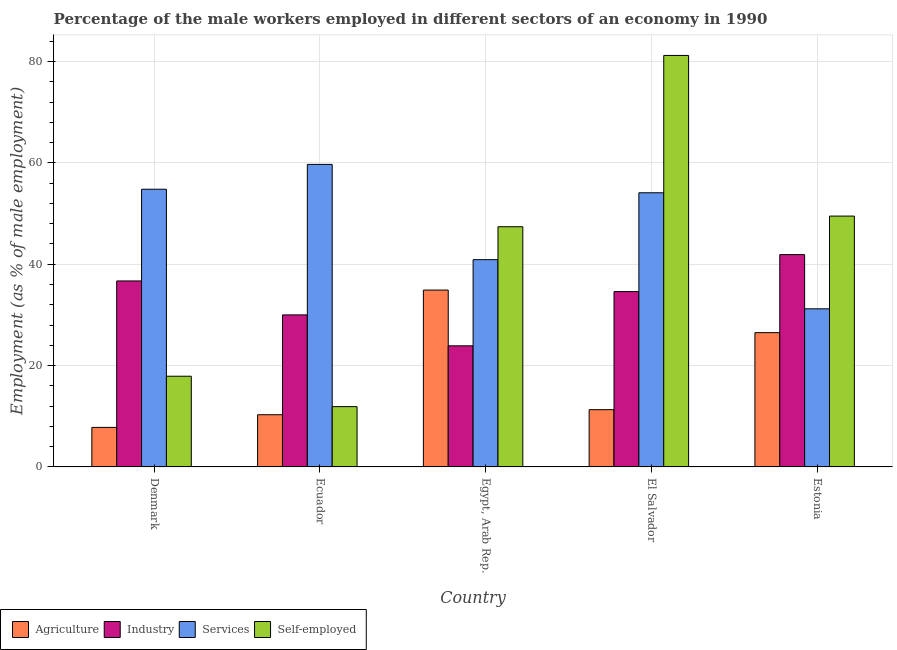How many groups of bars are there?
Your answer should be very brief. 5. How many bars are there on the 1st tick from the left?
Offer a very short reply. 4. What is the label of the 5th group of bars from the left?
Provide a succinct answer. Estonia. In how many cases, is the number of bars for a given country not equal to the number of legend labels?
Make the answer very short. 0. What is the percentage of male workers in industry in Estonia?
Provide a short and direct response. 41.9. Across all countries, what is the maximum percentage of male workers in industry?
Offer a terse response. 41.9. Across all countries, what is the minimum percentage of male workers in services?
Give a very brief answer. 31.2. In which country was the percentage of self employed male workers maximum?
Provide a short and direct response. El Salvador. In which country was the percentage of male workers in services minimum?
Your response must be concise. Estonia. What is the total percentage of male workers in services in the graph?
Your answer should be very brief. 240.7. What is the difference between the percentage of male workers in industry in Ecuador and that in Estonia?
Give a very brief answer. -11.9. What is the difference between the percentage of male workers in industry in Ecuador and the percentage of male workers in agriculture in Egypt, Arab Rep.?
Your answer should be compact. -4.9. What is the average percentage of male workers in industry per country?
Your answer should be compact. 33.42. What is the difference between the percentage of male workers in industry and percentage of male workers in services in Egypt, Arab Rep.?
Your answer should be compact. -17. In how many countries, is the percentage of male workers in agriculture greater than 28 %?
Keep it short and to the point. 1. What is the ratio of the percentage of male workers in services in Denmark to that in El Salvador?
Provide a succinct answer. 1.01. What is the difference between the highest and the second highest percentage of male workers in agriculture?
Provide a succinct answer. 8.4. What is the difference between the highest and the lowest percentage of male workers in services?
Your response must be concise. 28.5. Is the sum of the percentage of male workers in industry in Egypt, Arab Rep. and Estonia greater than the maximum percentage of self employed male workers across all countries?
Offer a terse response. No. Is it the case that in every country, the sum of the percentage of self employed male workers and percentage of male workers in agriculture is greater than the sum of percentage of male workers in services and percentage of male workers in industry?
Offer a terse response. No. What does the 2nd bar from the left in El Salvador represents?
Make the answer very short. Industry. What does the 3rd bar from the right in Ecuador represents?
Provide a succinct answer. Industry. How many bars are there?
Provide a short and direct response. 20. Are all the bars in the graph horizontal?
Offer a very short reply. No. How many countries are there in the graph?
Your answer should be compact. 5. Are the values on the major ticks of Y-axis written in scientific E-notation?
Offer a very short reply. No. Does the graph contain any zero values?
Your answer should be compact. No. Where does the legend appear in the graph?
Keep it short and to the point. Bottom left. How many legend labels are there?
Offer a terse response. 4. How are the legend labels stacked?
Your answer should be very brief. Horizontal. What is the title of the graph?
Your response must be concise. Percentage of the male workers employed in different sectors of an economy in 1990. Does "International Monetary Fund" appear as one of the legend labels in the graph?
Make the answer very short. No. What is the label or title of the X-axis?
Keep it short and to the point. Country. What is the label or title of the Y-axis?
Your response must be concise. Employment (as % of male employment). What is the Employment (as % of male employment) of Agriculture in Denmark?
Provide a succinct answer. 7.8. What is the Employment (as % of male employment) of Industry in Denmark?
Offer a terse response. 36.7. What is the Employment (as % of male employment) in Services in Denmark?
Give a very brief answer. 54.8. What is the Employment (as % of male employment) in Self-employed in Denmark?
Provide a short and direct response. 17.9. What is the Employment (as % of male employment) in Agriculture in Ecuador?
Your response must be concise. 10.3. What is the Employment (as % of male employment) of Services in Ecuador?
Make the answer very short. 59.7. What is the Employment (as % of male employment) of Self-employed in Ecuador?
Offer a very short reply. 11.9. What is the Employment (as % of male employment) of Agriculture in Egypt, Arab Rep.?
Provide a succinct answer. 34.9. What is the Employment (as % of male employment) in Industry in Egypt, Arab Rep.?
Offer a terse response. 23.9. What is the Employment (as % of male employment) of Services in Egypt, Arab Rep.?
Ensure brevity in your answer.  40.9. What is the Employment (as % of male employment) of Self-employed in Egypt, Arab Rep.?
Provide a succinct answer. 47.4. What is the Employment (as % of male employment) in Agriculture in El Salvador?
Keep it short and to the point. 11.3. What is the Employment (as % of male employment) of Industry in El Salvador?
Provide a succinct answer. 34.6. What is the Employment (as % of male employment) in Services in El Salvador?
Offer a terse response. 54.1. What is the Employment (as % of male employment) in Self-employed in El Salvador?
Your answer should be compact. 81.2. What is the Employment (as % of male employment) of Industry in Estonia?
Your response must be concise. 41.9. What is the Employment (as % of male employment) in Services in Estonia?
Your answer should be very brief. 31.2. What is the Employment (as % of male employment) in Self-employed in Estonia?
Give a very brief answer. 49.5. Across all countries, what is the maximum Employment (as % of male employment) in Agriculture?
Your answer should be compact. 34.9. Across all countries, what is the maximum Employment (as % of male employment) in Industry?
Ensure brevity in your answer.  41.9. Across all countries, what is the maximum Employment (as % of male employment) of Services?
Offer a terse response. 59.7. Across all countries, what is the maximum Employment (as % of male employment) of Self-employed?
Provide a succinct answer. 81.2. Across all countries, what is the minimum Employment (as % of male employment) in Agriculture?
Your answer should be very brief. 7.8. Across all countries, what is the minimum Employment (as % of male employment) of Industry?
Ensure brevity in your answer.  23.9. Across all countries, what is the minimum Employment (as % of male employment) of Services?
Ensure brevity in your answer.  31.2. Across all countries, what is the minimum Employment (as % of male employment) of Self-employed?
Provide a succinct answer. 11.9. What is the total Employment (as % of male employment) of Agriculture in the graph?
Offer a terse response. 90.8. What is the total Employment (as % of male employment) of Industry in the graph?
Offer a terse response. 167.1. What is the total Employment (as % of male employment) in Services in the graph?
Provide a succinct answer. 240.7. What is the total Employment (as % of male employment) in Self-employed in the graph?
Your response must be concise. 207.9. What is the difference between the Employment (as % of male employment) of Agriculture in Denmark and that in Ecuador?
Ensure brevity in your answer.  -2.5. What is the difference between the Employment (as % of male employment) of Services in Denmark and that in Ecuador?
Offer a very short reply. -4.9. What is the difference between the Employment (as % of male employment) of Agriculture in Denmark and that in Egypt, Arab Rep.?
Keep it short and to the point. -27.1. What is the difference between the Employment (as % of male employment) of Industry in Denmark and that in Egypt, Arab Rep.?
Your answer should be compact. 12.8. What is the difference between the Employment (as % of male employment) of Services in Denmark and that in Egypt, Arab Rep.?
Offer a terse response. 13.9. What is the difference between the Employment (as % of male employment) in Self-employed in Denmark and that in Egypt, Arab Rep.?
Your answer should be compact. -29.5. What is the difference between the Employment (as % of male employment) of Industry in Denmark and that in El Salvador?
Give a very brief answer. 2.1. What is the difference between the Employment (as % of male employment) in Self-employed in Denmark and that in El Salvador?
Your answer should be very brief. -63.3. What is the difference between the Employment (as % of male employment) in Agriculture in Denmark and that in Estonia?
Your response must be concise. -18.7. What is the difference between the Employment (as % of male employment) of Services in Denmark and that in Estonia?
Make the answer very short. 23.6. What is the difference between the Employment (as % of male employment) of Self-employed in Denmark and that in Estonia?
Provide a short and direct response. -31.6. What is the difference between the Employment (as % of male employment) of Agriculture in Ecuador and that in Egypt, Arab Rep.?
Make the answer very short. -24.6. What is the difference between the Employment (as % of male employment) of Self-employed in Ecuador and that in Egypt, Arab Rep.?
Provide a short and direct response. -35.5. What is the difference between the Employment (as % of male employment) in Agriculture in Ecuador and that in El Salvador?
Your answer should be compact. -1. What is the difference between the Employment (as % of male employment) of Self-employed in Ecuador and that in El Salvador?
Ensure brevity in your answer.  -69.3. What is the difference between the Employment (as % of male employment) of Agriculture in Ecuador and that in Estonia?
Offer a very short reply. -16.2. What is the difference between the Employment (as % of male employment) in Services in Ecuador and that in Estonia?
Offer a terse response. 28.5. What is the difference between the Employment (as % of male employment) in Self-employed in Ecuador and that in Estonia?
Your answer should be very brief. -37.6. What is the difference between the Employment (as % of male employment) in Agriculture in Egypt, Arab Rep. and that in El Salvador?
Offer a terse response. 23.6. What is the difference between the Employment (as % of male employment) in Services in Egypt, Arab Rep. and that in El Salvador?
Keep it short and to the point. -13.2. What is the difference between the Employment (as % of male employment) in Self-employed in Egypt, Arab Rep. and that in El Salvador?
Keep it short and to the point. -33.8. What is the difference between the Employment (as % of male employment) of Agriculture in El Salvador and that in Estonia?
Offer a very short reply. -15.2. What is the difference between the Employment (as % of male employment) of Industry in El Salvador and that in Estonia?
Give a very brief answer. -7.3. What is the difference between the Employment (as % of male employment) of Services in El Salvador and that in Estonia?
Make the answer very short. 22.9. What is the difference between the Employment (as % of male employment) of Self-employed in El Salvador and that in Estonia?
Keep it short and to the point. 31.7. What is the difference between the Employment (as % of male employment) of Agriculture in Denmark and the Employment (as % of male employment) of Industry in Ecuador?
Offer a very short reply. -22.2. What is the difference between the Employment (as % of male employment) of Agriculture in Denmark and the Employment (as % of male employment) of Services in Ecuador?
Your answer should be very brief. -51.9. What is the difference between the Employment (as % of male employment) of Industry in Denmark and the Employment (as % of male employment) of Services in Ecuador?
Provide a succinct answer. -23. What is the difference between the Employment (as % of male employment) in Industry in Denmark and the Employment (as % of male employment) in Self-employed in Ecuador?
Provide a succinct answer. 24.8. What is the difference between the Employment (as % of male employment) in Services in Denmark and the Employment (as % of male employment) in Self-employed in Ecuador?
Provide a short and direct response. 42.9. What is the difference between the Employment (as % of male employment) of Agriculture in Denmark and the Employment (as % of male employment) of Industry in Egypt, Arab Rep.?
Make the answer very short. -16.1. What is the difference between the Employment (as % of male employment) in Agriculture in Denmark and the Employment (as % of male employment) in Services in Egypt, Arab Rep.?
Your response must be concise. -33.1. What is the difference between the Employment (as % of male employment) of Agriculture in Denmark and the Employment (as % of male employment) of Self-employed in Egypt, Arab Rep.?
Your response must be concise. -39.6. What is the difference between the Employment (as % of male employment) in Industry in Denmark and the Employment (as % of male employment) in Services in Egypt, Arab Rep.?
Offer a very short reply. -4.2. What is the difference between the Employment (as % of male employment) of Industry in Denmark and the Employment (as % of male employment) of Self-employed in Egypt, Arab Rep.?
Offer a terse response. -10.7. What is the difference between the Employment (as % of male employment) of Agriculture in Denmark and the Employment (as % of male employment) of Industry in El Salvador?
Your answer should be very brief. -26.8. What is the difference between the Employment (as % of male employment) in Agriculture in Denmark and the Employment (as % of male employment) in Services in El Salvador?
Your answer should be compact. -46.3. What is the difference between the Employment (as % of male employment) of Agriculture in Denmark and the Employment (as % of male employment) of Self-employed in El Salvador?
Your response must be concise. -73.4. What is the difference between the Employment (as % of male employment) of Industry in Denmark and the Employment (as % of male employment) of Services in El Salvador?
Make the answer very short. -17.4. What is the difference between the Employment (as % of male employment) in Industry in Denmark and the Employment (as % of male employment) in Self-employed in El Salvador?
Provide a short and direct response. -44.5. What is the difference between the Employment (as % of male employment) of Services in Denmark and the Employment (as % of male employment) of Self-employed in El Salvador?
Your response must be concise. -26.4. What is the difference between the Employment (as % of male employment) in Agriculture in Denmark and the Employment (as % of male employment) in Industry in Estonia?
Offer a terse response. -34.1. What is the difference between the Employment (as % of male employment) in Agriculture in Denmark and the Employment (as % of male employment) in Services in Estonia?
Your answer should be compact. -23.4. What is the difference between the Employment (as % of male employment) of Agriculture in Denmark and the Employment (as % of male employment) of Self-employed in Estonia?
Your answer should be very brief. -41.7. What is the difference between the Employment (as % of male employment) of Industry in Denmark and the Employment (as % of male employment) of Services in Estonia?
Your response must be concise. 5.5. What is the difference between the Employment (as % of male employment) in Industry in Denmark and the Employment (as % of male employment) in Self-employed in Estonia?
Offer a terse response. -12.8. What is the difference between the Employment (as % of male employment) in Services in Denmark and the Employment (as % of male employment) in Self-employed in Estonia?
Your answer should be very brief. 5.3. What is the difference between the Employment (as % of male employment) of Agriculture in Ecuador and the Employment (as % of male employment) of Services in Egypt, Arab Rep.?
Ensure brevity in your answer.  -30.6. What is the difference between the Employment (as % of male employment) in Agriculture in Ecuador and the Employment (as % of male employment) in Self-employed in Egypt, Arab Rep.?
Your answer should be very brief. -37.1. What is the difference between the Employment (as % of male employment) in Industry in Ecuador and the Employment (as % of male employment) in Services in Egypt, Arab Rep.?
Offer a very short reply. -10.9. What is the difference between the Employment (as % of male employment) of Industry in Ecuador and the Employment (as % of male employment) of Self-employed in Egypt, Arab Rep.?
Ensure brevity in your answer.  -17.4. What is the difference between the Employment (as % of male employment) of Services in Ecuador and the Employment (as % of male employment) of Self-employed in Egypt, Arab Rep.?
Your answer should be very brief. 12.3. What is the difference between the Employment (as % of male employment) of Agriculture in Ecuador and the Employment (as % of male employment) of Industry in El Salvador?
Offer a very short reply. -24.3. What is the difference between the Employment (as % of male employment) in Agriculture in Ecuador and the Employment (as % of male employment) in Services in El Salvador?
Offer a terse response. -43.8. What is the difference between the Employment (as % of male employment) in Agriculture in Ecuador and the Employment (as % of male employment) in Self-employed in El Salvador?
Offer a terse response. -70.9. What is the difference between the Employment (as % of male employment) of Industry in Ecuador and the Employment (as % of male employment) of Services in El Salvador?
Your response must be concise. -24.1. What is the difference between the Employment (as % of male employment) of Industry in Ecuador and the Employment (as % of male employment) of Self-employed in El Salvador?
Offer a terse response. -51.2. What is the difference between the Employment (as % of male employment) in Services in Ecuador and the Employment (as % of male employment) in Self-employed in El Salvador?
Your answer should be very brief. -21.5. What is the difference between the Employment (as % of male employment) of Agriculture in Ecuador and the Employment (as % of male employment) of Industry in Estonia?
Your response must be concise. -31.6. What is the difference between the Employment (as % of male employment) in Agriculture in Ecuador and the Employment (as % of male employment) in Services in Estonia?
Offer a terse response. -20.9. What is the difference between the Employment (as % of male employment) of Agriculture in Ecuador and the Employment (as % of male employment) of Self-employed in Estonia?
Your response must be concise. -39.2. What is the difference between the Employment (as % of male employment) of Industry in Ecuador and the Employment (as % of male employment) of Self-employed in Estonia?
Make the answer very short. -19.5. What is the difference between the Employment (as % of male employment) of Agriculture in Egypt, Arab Rep. and the Employment (as % of male employment) of Services in El Salvador?
Provide a succinct answer. -19.2. What is the difference between the Employment (as % of male employment) of Agriculture in Egypt, Arab Rep. and the Employment (as % of male employment) of Self-employed in El Salvador?
Provide a short and direct response. -46.3. What is the difference between the Employment (as % of male employment) in Industry in Egypt, Arab Rep. and the Employment (as % of male employment) in Services in El Salvador?
Make the answer very short. -30.2. What is the difference between the Employment (as % of male employment) of Industry in Egypt, Arab Rep. and the Employment (as % of male employment) of Self-employed in El Salvador?
Ensure brevity in your answer.  -57.3. What is the difference between the Employment (as % of male employment) of Services in Egypt, Arab Rep. and the Employment (as % of male employment) of Self-employed in El Salvador?
Keep it short and to the point. -40.3. What is the difference between the Employment (as % of male employment) of Agriculture in Egypt, Arab Rep. and the Employment (as % of male employment) of Services in Estonia?
Your response must be concise. 3.7. What is the difference between the Employment (as % of male employment) in Agriculture in Egypt, Arab Rep. and the Employment (as % of male employment) in Self-employed in Estonia?
Give a very brief answer. -14.6. What is the difference between the Employment (as % of male employment) in Industry in Egypt, Arab Rep. and the Employment (as % of male employment) in Self-employed in Estonia?
Make the answer very short. -25.6. What is the difference between the Employment (as % of male employment) in Agriculture in El Salvador and the Employment (as % of male employment) in Industry in Estonia?
Your response must be concise. -30.6. What is the difference between the Employment (as % of male employment) of Agriculture in El Salvador and the Employment (as % of male employment) of Services in Estonia?
Your response must be concise. -19.9. What is the difference between the Employment (as % of male employment) in Agriculture in El Salvador and the Employment (as % of male employment) in Self-employed in Estonia?
Your response must be concise. -38.2. What is the difference between the Employment (as % of male employment) of Industry in El Salvador and the Employment (as % of male employment) of Services in Estonia?
Your answer should be compact. 3.4. What is the difference between the Employment (as % of male employment) in Industry in El Salvador and the Employment (as % of male employment) in Self-employed in Estonia?
Your answer should be compact. -14.9. What is the average Employment (as % of male employment) of Agriculture per country?
Ensure brevity in your answer.  18.16. What is the average Employment (as % of male employment) of Industry per country?
Keep it short and to the point. 33.42. What is the average Employment (as % of male employment) of Services per country?
Offer a very short reply. 48.14. What is the average Employment (as % of male employment) of Self-employed per country?
Offer a terse response. 41.58. What is the difference between the Employment (as % of male employment) in Agriculture and Employment (as % of male employment) in Industry in Denmark?
Ensure brevity in your answer.  -28.9. What is the difference between the Employment (as % of male employment) of Agriculture and Employment (as % of male employment) of Services in Denmark?
Offer a very short reply. -47. What is the difference between the Employment (as % of male employment) in Industry and Employment (as % of male employment) in Services in Denmark?
Make the answer very short. -18.1. What is the difference between the Employment (as % of male employment) of Services and Employment (as % of male employment) of Self-employed in Denmark?
Keep it short and to the point. 36.9. What is the difference between the Employment (as % of male employment) of Agriculture and Employment (as % of male employment) of Industry in Ecuador?
Provide a short and direct response. -19.7. What is the difference between the Employment (as % of male employment) in Agriculture and Employment (as % of male employment) in Services in Ecuador?
Give a very brief answer. -49.4. What is the difference between the Employment (as % of male employment) of Agriculture and Employment (as % of male employment) of Self-employed in Ecuador?
Your response must be concise. -1.6. What is the difference between the Employment (as % of male employment) of Industry and Employment (as % of male employment) of Services in Ecuador?
Offer a terse response. -29.7. What is the difference between the Employment (as % of male employment) of Services and Employment (as % of male employment) of Self-employed in Ecuador?
Provide a succinct answer. 47.8. What is the difference between the Employment (as % of male employment) of Agriculture and Employment (as % of male employment) of Industry in Egypt, Arab Rep.?
Your answer should be very brief. 11. What is the difference between the Employment (as % of male employment) of Agriculture and Employment (as % of male employment) of Services in Egypt, Arab Rep.?
Keep it short and to the point. -6. What is the difference between the Employment (as % of male employment) in Industry and Employment (as % of male employment) in Self-employed in Egypt, Arab Rep.?
Ensure brevity in your answer.  -23.5. What is the difference between the Employment (as % of male employment) of Agriculture and Employment (as % of male employment) of Industry in El Salvador?
Give a very brief answer. -23.3. What is the difference between the Employment (as % of male employment) in Agriculture and Employment (as % of male employment) in Services in El Salvador?
Give a very brief answer. -42.8. What is the difference between the Employment (as % of male employment) of Agriculture and Employment (as % of male employment) of Self-employed in El Salvador?
Offer a terse response. -69.9. What is the difference between the Employment (as % of male employment) of Industry and Employment (as % of male employment) of Services in El Salvador?
Provide a succinct answer. -19.5. What is the difference between the Employment (as % of male employment) in Industry and Employment (as % of male employment) in Self-employed in El Salvador?
Offer a very short reply. -46.6. What is the difference between the Employment (as % of male employment) in Services and Employment (as % of male employment) in Self-employed in El Salvador?
Ensure brevity in your answer.  -27.1. What is the difference between the Employment (as % of male employment) in Agriculture and Employment (as % of male employment) in Industry in Estonia?
Ensure brevity in your answer.  -15.4. What is the difference between the Employment (as % of male employment) of Agriculture and Employment (as % of male employment) of Self-employed in Estonia?
Offer a very short reply. -23. What is the difference between the Employment (as % of male employment) of Industry and Employment (as % of male employment) of Self-employed in Estonia?
Give a very brief answer. -7.6. What is the difference between the Employment (as % of male employment) in Services and Employment (as % of male employment) in Self-employed in Estonia?
Provide a short and direct response. -18.3. What is the ratio of the Employment (as % of male employment) of Agriculture in Denmark to that in Ecuador?
Offer a very short reply. 0.76. What is the ratio of the Employment (as % of male employment) in Industry in Denmark to that in Ecuador?
Ensure brevity in your answer.  1.22. What is the ratio of the Employment (as % of male employment) in Services in Denmark to that in Ecuador?
Offer a very short reply. 0.92. What is the ratio of the Employment (as % of male employment) of Self-employed in Denmark to that in Ecuador?
Keep it short and to the point. 1.5. What is the ratio of the Employment (as % of male employment) of Agriculture in Denmark to that in Egypt, Arab Rep.?
Your answer should be compact. 0.22. What is the ratio of the Employment (as % of male employment) of Industry in Denmark to that in Egypt, Arab Rep.?
Give a very brief answer. 1.54. What is the ratio of the Employment (as % of male employment) in Services in Denmark to that in Egypt, Arab Rep.?
Your answer should be compact. 1.34. What is the ratio of the Employment (as % of male employment) of Self-employed in Denmark to that in Egypt, Arab Rep.?
Your answer should be very brief. 0.38. What is the ratio of the Employment (as % of male employment) of Agriculture in Denmark to that in El Salvador?
Your answer should be compact. 0.69. What is the ratio of the Employment (as % of male employment) in Industry in Denmark to that in El Salvador?
Give a very brief answer. 1.06. What is the ratio of the Employment (as % of male employment) in Services in Denmark to that in El Salvador?
Ensure brevity in your answer.  1.01. What is the ratio of the Employment (as % of male employment) of Self-employed in Denmark to that in El Salvador?
Make the answer very short. 0.22. What is the ratio of the Employment (as % of male employment) in Agriculture in Denmark to that in Estonia?
Offer a terse response. 0.29. What is the ratio of the Employment (as % of male employment) of Industry in Denmark to that in Estonia?
Your answer should be compact. 0.88. What is the ratio of the Employment (as % of male employment) of Services in Denmark to that in Estonia?
Ensure brevity in your answer.  1.76. What is the ratio of the Employment (as % of male employment) in Self-employed in Denmark to that in Estonia?
Make the answer very short. 0.36. What is the ratio of the Employment (as % of male employment) in Agriculture in Ecuador to that in Egypt, Arab Rep.?
Ensure brevity in your answer.  0.3. What is the ratio of the Employment (as % of male employment) in Industry in Ecuador to that in Egypt, Arab Rep.?
Provide a short and direct response. 1.26. What is the ratio of the Employment (as % of male employment) of Services in Ecuador to that in Egypt, Arab Rep.?
Make the answer very short. 1.46. What is the ratio of the Employment (as % of male employment) of Self-employed in Ecuador to that in Egypt, Arab Rep.?
Make the answer very short. 0.25. What is the ratio of the Employment (as % of male employment) of Agriculture in Ecuador to that in El Salvador?
Offer a terse response. 0.91. What is the ratio of the Employment (as % of male employment) of Industry in Ecuador to that in El Salvador?
Your answer should be compact. 0.87. What is the ratio of the Employment (as % of male employment) in Services in Ecuador to that in El Salvador?
Your answer should be very brief. 1.1. What is the ratio of the Employment (as % of male employment) of Self-employed in Ecuador to that in El Salvador?
Offer a terse response. 0.15. What is the ratio of the Employment (as % of male employment) in Agriculture in Ecuador to that in Estonia?
Provide a short and direct response. 0.39. What is the ratio of the Employment (as % of male employment) of Industry in Ecuador to that in Estonia?
Provide a succinct answer. 0.72. What is the ratio of the Employment (as % of male employment) in Services in Ecuador to that in Estonia?
Provide a succinct answer. 1.91. What is the ratio of the Employment (as % of male employment) of Self-employed in Ecuador to that in Estonia?
Offer a terse response. 0.24. What is the ratio of the Employment (as % of male employment) in Agriculture in Egypt, Arab Rep. to that in El Salvador?
Your answer should be very brief. 3.09. What is the ratio of the Employment (as % of male employment) in Industry in Egypt, Arab Rep. to that in El Salvador?
Provide a short and direct response. 0.69. What is the ratio of the Employment (as % of male employment) in Services in Egypt, Arab Rep. to that in El Salvador?
Offer a very short reply. 0.76. What is the ratio of the Employment (as % of male employment) in Self-employed in Egypt, Arab Rep. to that in El Salvador?
Offer a very short reply. 0.58. What is the ratio of the Employment (as % of male employment) of Agriculture in Egypt, Arab Rep. to that in Estonia?
Make the answer very short. 1.32. What is the ratio of the Employment (as % of male employment) in Industry in Egypt, Arab Rep. to that in Estonia?
Provide a short and direct response. 0.57. What is the ratio of the Employment (as % of male employment) in Services in Egypt, Arab Rep. to that in Estonia?
Ensure brevity in your answer.  1.31. What is the ratio of the Employment (as % of male employment) of Self-employed in Egypt, Arab Rep. to that in Estonia?
Give a very brief answer. 0.96. What is the ratio of the Employment (as % of male employment) in Agriculture in El Salvador to that in Estonia?
Give a very brief answer. 0.43. What is the ratio of the Employment (as % of male employment) of Industry in El Salvador to that in Estonia?
Give a very brief answer. 0.83. What is the ratio of the Employment (as % of male employment) in Services in El Salvador to that in Estonia?
Your answer should be compact. 1.73. What is the ratio of the Employment (as % of male employment) in Self-employed in El Salvador to that in Estonia?
Offer a very short reply. 1.64. What is the difference between the highest and the second highest Employment (as % of male employment) of Agriculture?
Make the answer very short. 8.4. What is the difference between the highest and the second highest Employment (as % of male employment) in Services?
Your response must be concise. 4.9. What is the difference between the highest and the second highest Employment (as % of male employment) of Self-employed?
Offer a terse response. 31.7. What is the difference between the highest and the lowest Employment (as % of male employment) of Agriculture?
Make the answer very short. 27.1. What is the difference between the highest and the lowest Employment (as % of male employment) in Services?
Offer a terse response. 28.5. What is the difference between the highest and the lowest Employment (as % of male employment) in Self-employed?
Provide a succinct answer. 69.3. 